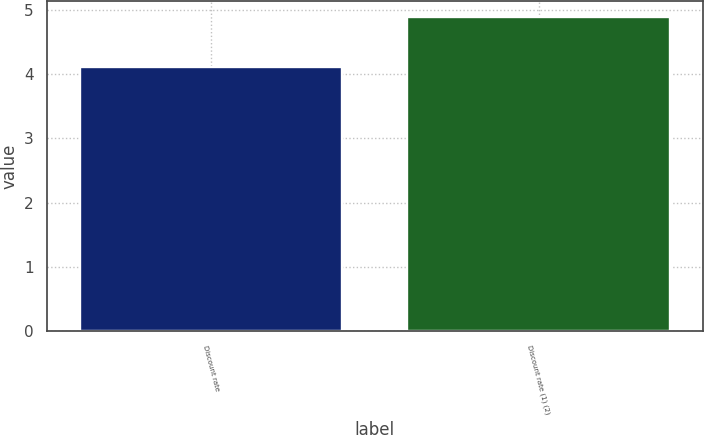Convert chart to OTSL. <chart><loc_0><loc_0><loc_500><loc_500><bar_chart><fcel>Discount rate<fcel>Discount rate (1) (2)<nl><fcel>4.12<fcel>4.89<nl></chart> 